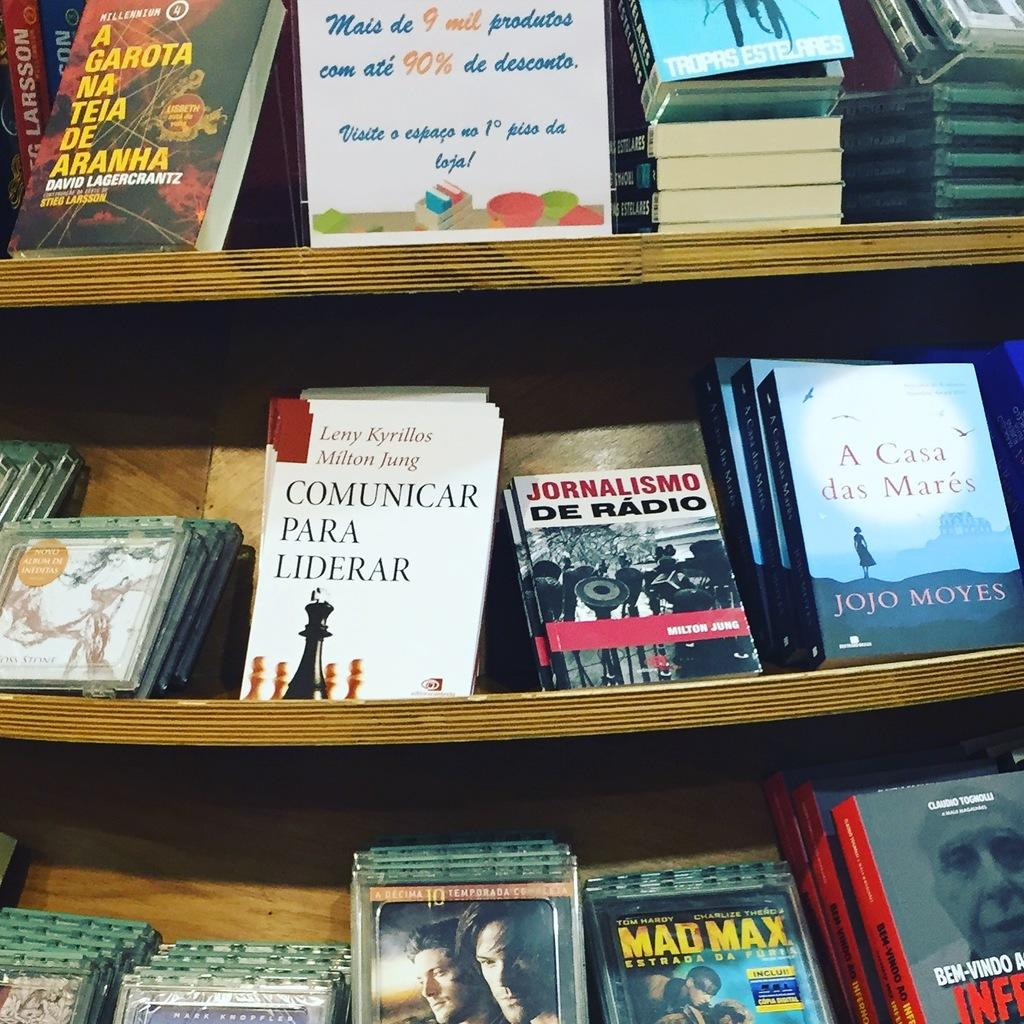<image>
Summarize the visual content of the image. A display shelf showing books and movies including mad max among others. 